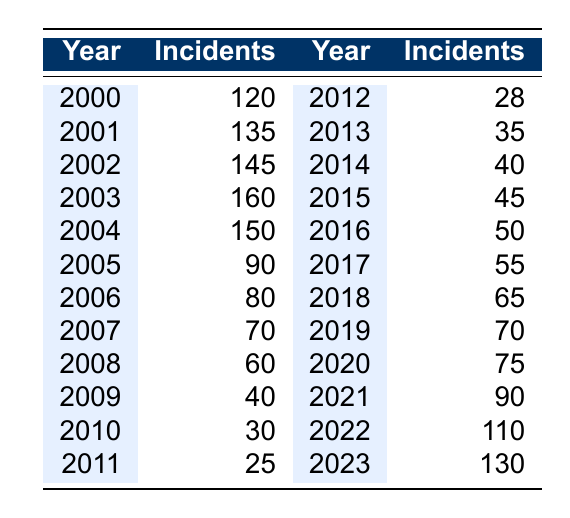What was the highest reported number of corporate fraud incidents? The highest number in the "Incidents" column is 160, which corresponds to the year 2003, making it the maximum reported number of corporate fraud incidents.
Answer: 160 What trend can be observed from the years 2000 to 2005 regarding corporate fraud incidents? From 2000 to 2003, the number of incidents increased from 120 to 160 but then declined steadily to 90 by 2005. This indicates an initial rise followed by a notable decrease.
Answer: An increase followed by a decrease Which year saw the lowest number of reported incidents post-implementation of whistleblower protection laws? The data from 2010 shows that there were only 30 reported incidents, the lowest in the period after the laws were implemented (2010 onwards).
Answer: 30 How many corporate fraud incidents were reported in the year 2019? According to the table, the year 2019 reports 70 incidents.
Answer: 70 What is the average number of corporate fraud incidents reported from 2012 to 2023? To find the average, sum the incidents from 2012 (28) to 2023 (130). The total incidents = 28 + 35 + 40 + 45 + 50 + 55 + 65 + 70 + 75 + 90 + 110 + 130 = 825. There are 12 years in this range, so the average is 825 / 12 = 68.75.
Answer: 68.75 Did the number of corporate fraud incidents increase every year after 2013? Examining the years after 2013, the counts are: 40 (2014), 45 (2015), 50 (2016), 55 (2017), 65 (2018), 70 (2019), 75 (2020), 90 (2021), 110 (2022), and 130 (2023). Notably, the incidents increased each year after 2013 without any drops, confirming a consistent upward trend.
Answer: Yes What was the change in the number of incidents reported from 2004 to 2006? The incidents dropped from 150 in 2004 to 80 in 2006. The change is calculated as 80 - 150 = -70, indicating a decrease of 70 incidents within those years.
Answer: Decrease of 70 incidents Was there any year between 2010 to 2013 where the number of reported incidents was greater than in 2011? Checking the figures, in 2011 (25 incidents), 2012 (28 incidents), and 2013 (35 incidents) indicate that yes, both 2012 and 2013 reported more incidents than 2011.
Answer: Yes 